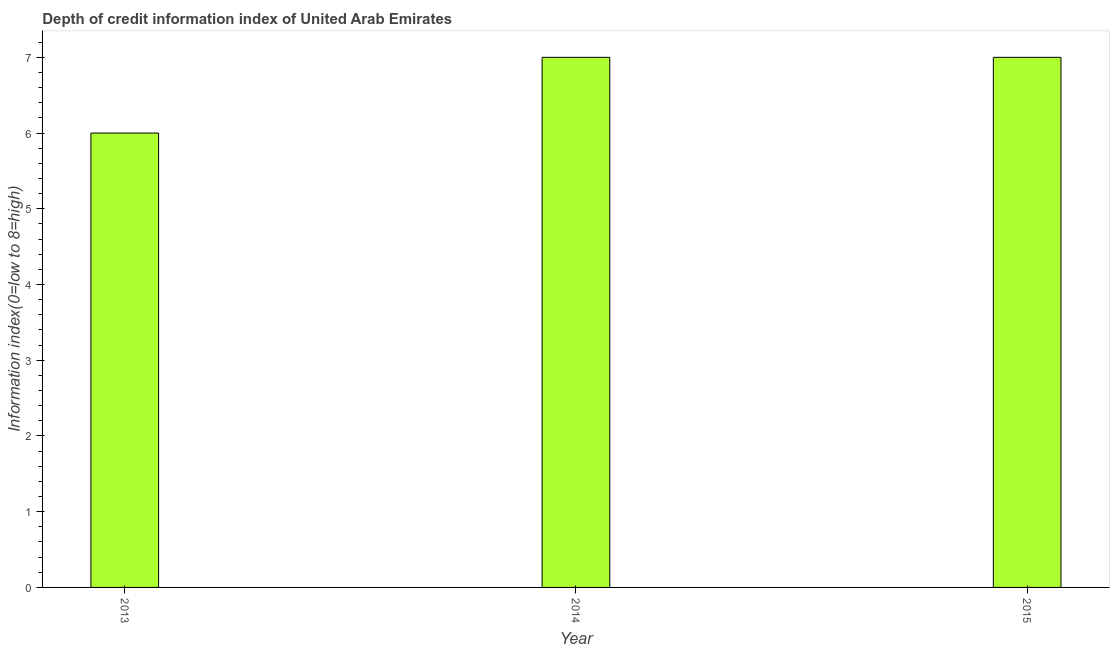Does the graph contain any zero values?
Make the answer very short. No. What is the title of the graph?
Give a very brief answer. Depth of credit information index of United Arab Emirates. What is the label or title of the Y-axis?
Your response must be concise. Information index(0=low to 8=high). Across all years, what is the minimum depth of credit information index?
Offer a terse response. 6. In which year was the depth of credit information index maximum?
Ensure brevity in your answer.  2014. What is the sum of the depth of credit information index?
Your response must be concise. 20. What is the average depth of credit information index per year?
Your response must be concise. 6. In how many years, is the depth of credit information index greater than 6.6 ?
Your answer should be very brief. 2. What is the ratio of the depth of credit information index in 2013 to that in 2014?
Your answer should be very brief. 0.86. Is the difference between the depth of credit information index in 2013 and 2015 greater than the difference between any two years?
Provide a succinct answer. Yes. Is the sum of the depth of credit information index in 2013 and 2015 greater than the maximum depth of credit information index across all years?
Make the answer very short. Yes. What is the difference between the highest and the lowest depth of credit information index?
Your answer should be compact. 1. In how many years, is the depth of credit information index greater than the average depth of credit information index taken over all years?
Offer a very short reply. 2. How many bars are there?
Your response must be concise. 3. What is the Information index(0=low to 8=high) of 2013?
Give a very brief answer. 6. What is the difference between the Information index(0=low to 8=high) in 2013 and 2015?
Give a very brief answer. -1. What is the ratio of the Information index(0=low to 8=high) in 2013 to that in 2014?
Your response must be concise. 0.86. What is the ratio of the Information index(0=low to 8=high) in 2013 to that in 2015?
Ensure brevity in your answer.  0.86. 